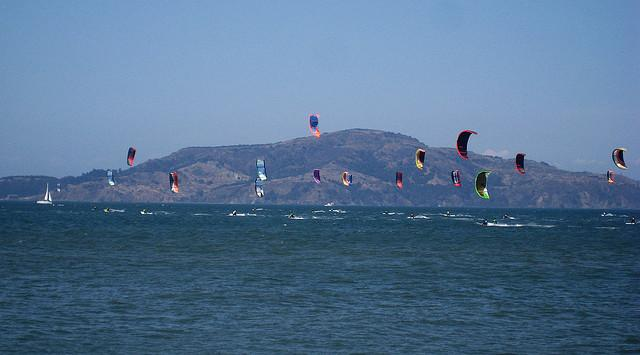Which direction does the wind blow?

Choices:
A) toward boat
B) rightward
C) from hills
D) up down toward boat 